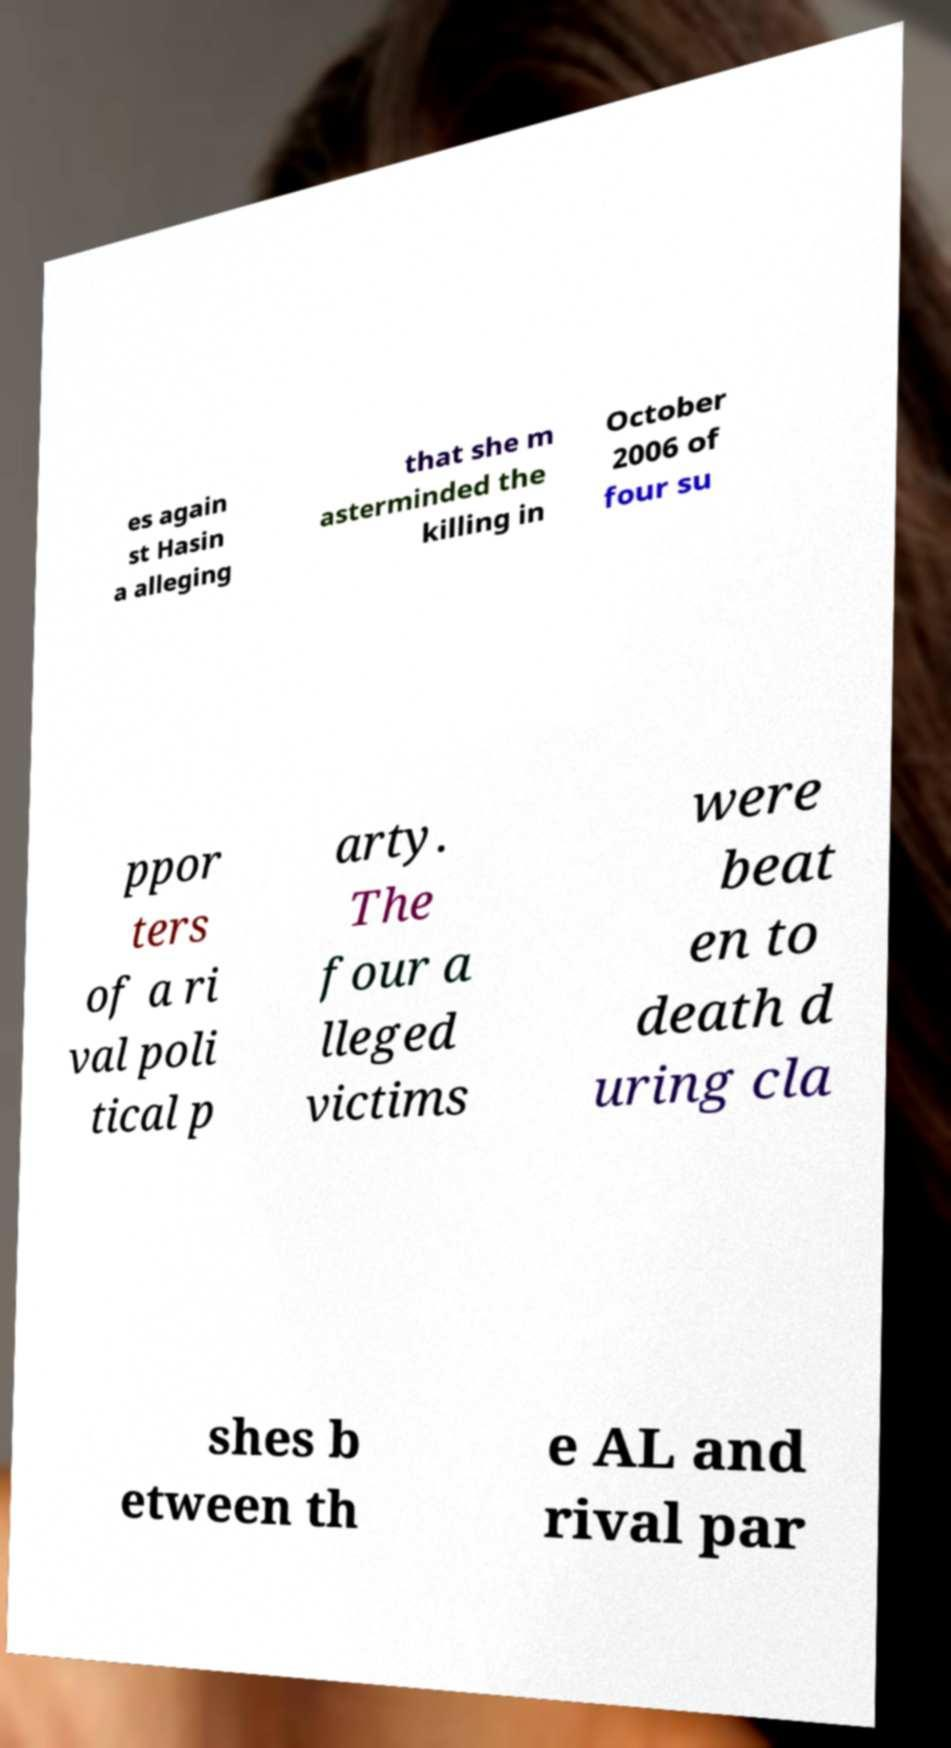Can you accurately transcribe the text from the provided image for me? es again st Hasin a alleging that she m asterminded the killing in October 2006 of four su ppor ters of a ri val poli tical p arty. The four a lleged victims were beat en to death d uring cla shes b etween th e AL and rival par 